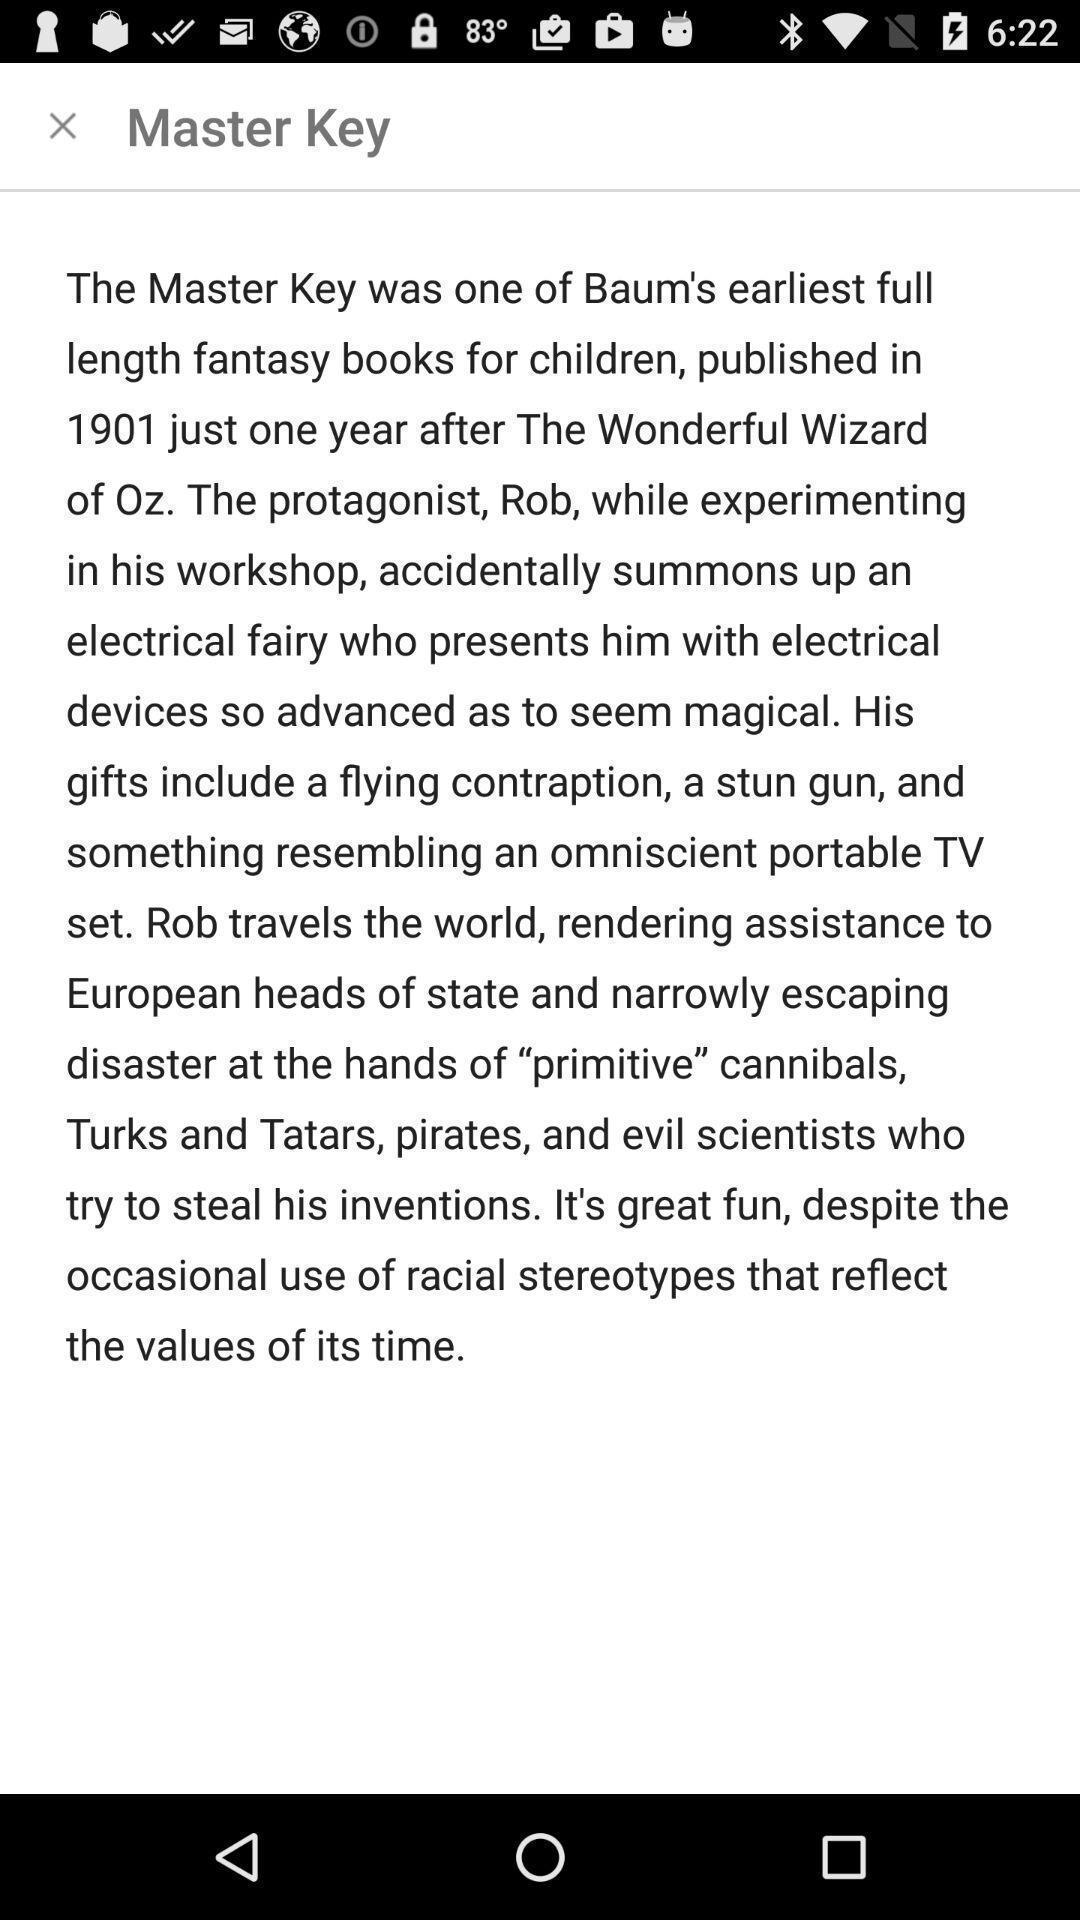Please provide a description for this image. Story in a audio books app. 